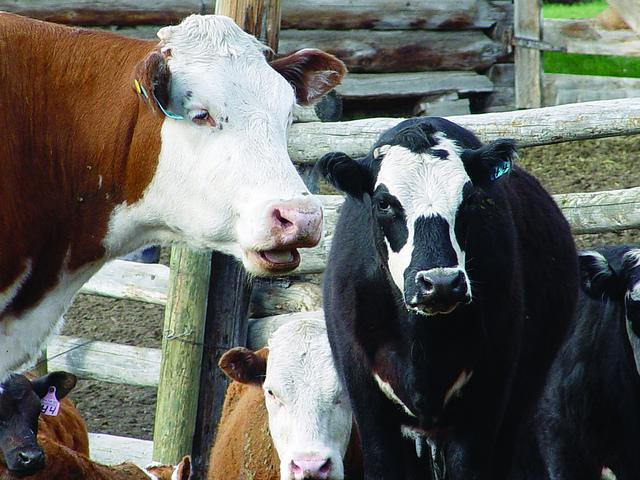Who put the tag on the cows ear? Please explain your reasoning. human. Only a person can apply a clip onto a cow's ear. 